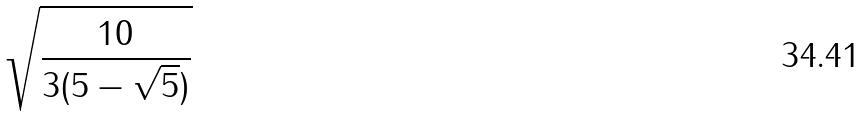Convert formula to latex. <formula><loc_0><loc_0><loc_500><loc_500>\sqrt { \frac { 1 0 } { 3 ( 5 - \sqrt { 5 } ) } }</formula> 